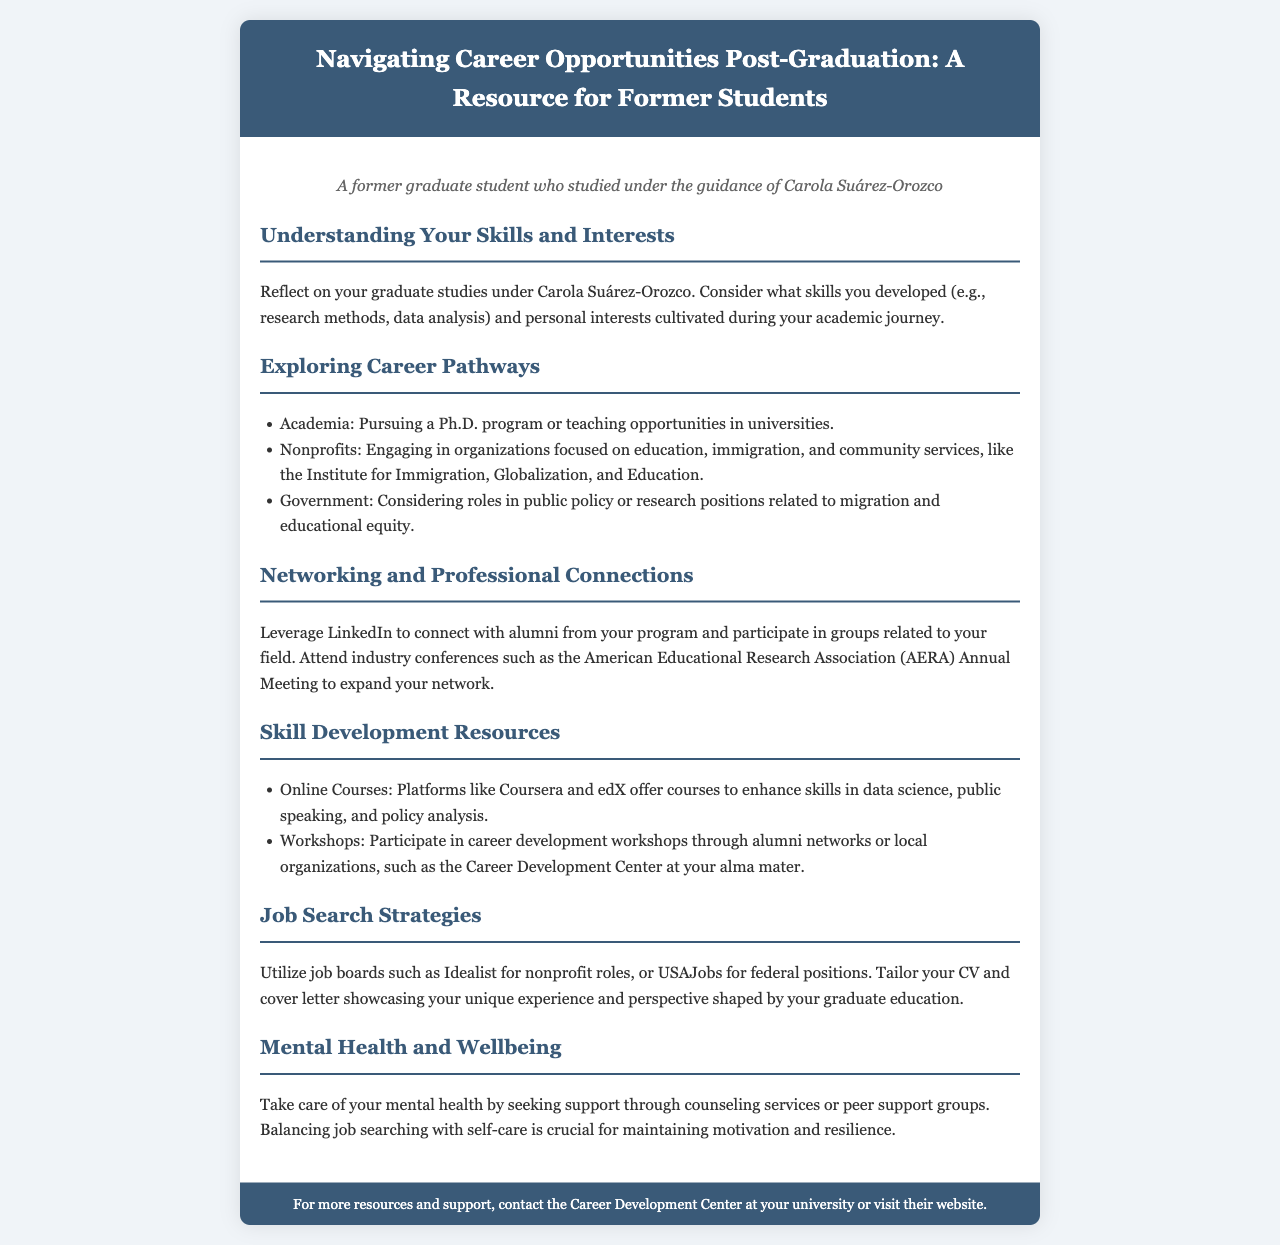What is the title of the brochure? The title is mentioned in the header section of the document.
Answer: Navigating Career Opportunities Post-Graduation: A Resource for Former Students Who is the intended audience of the brochure? The persona section specifies the audience that the brochure is addressing.
Answer: Former students What online platforms are suggested for skill enhancement? The document lists recommended platforms for online courses under skill development resources.
Answer: Coursera and edX What type of organizations are suggested for engagement in the nonprofit career pathway? The document specifies the focus of nonprofit organizations in the exploration of career pathways.
Answer: Education, immigration, and community services What annual meeting is recommended for networking? The document suggests a specific conference that is beneficial for networking in the field.
Answer: American Educational Research Association (AERA) Annual Meeting How should job applicants tailor their application materials? The document provides guidance on customizing application materials for job searches.
Answer: Showcasing unique experience and perspective What is one way to take care of mental health during job searching? The document emphasizes the importance of seeking support during job hunting.
Answer: Counseling services List one type of role considered in government career pathways. The document mentions potential career options in the government sector.
Answer: Public policy What is the significance of the Career Development Center mentioned in the footer? The footer provides a resource for further assistance post-graduation.
Answer: Support and resources for career development 